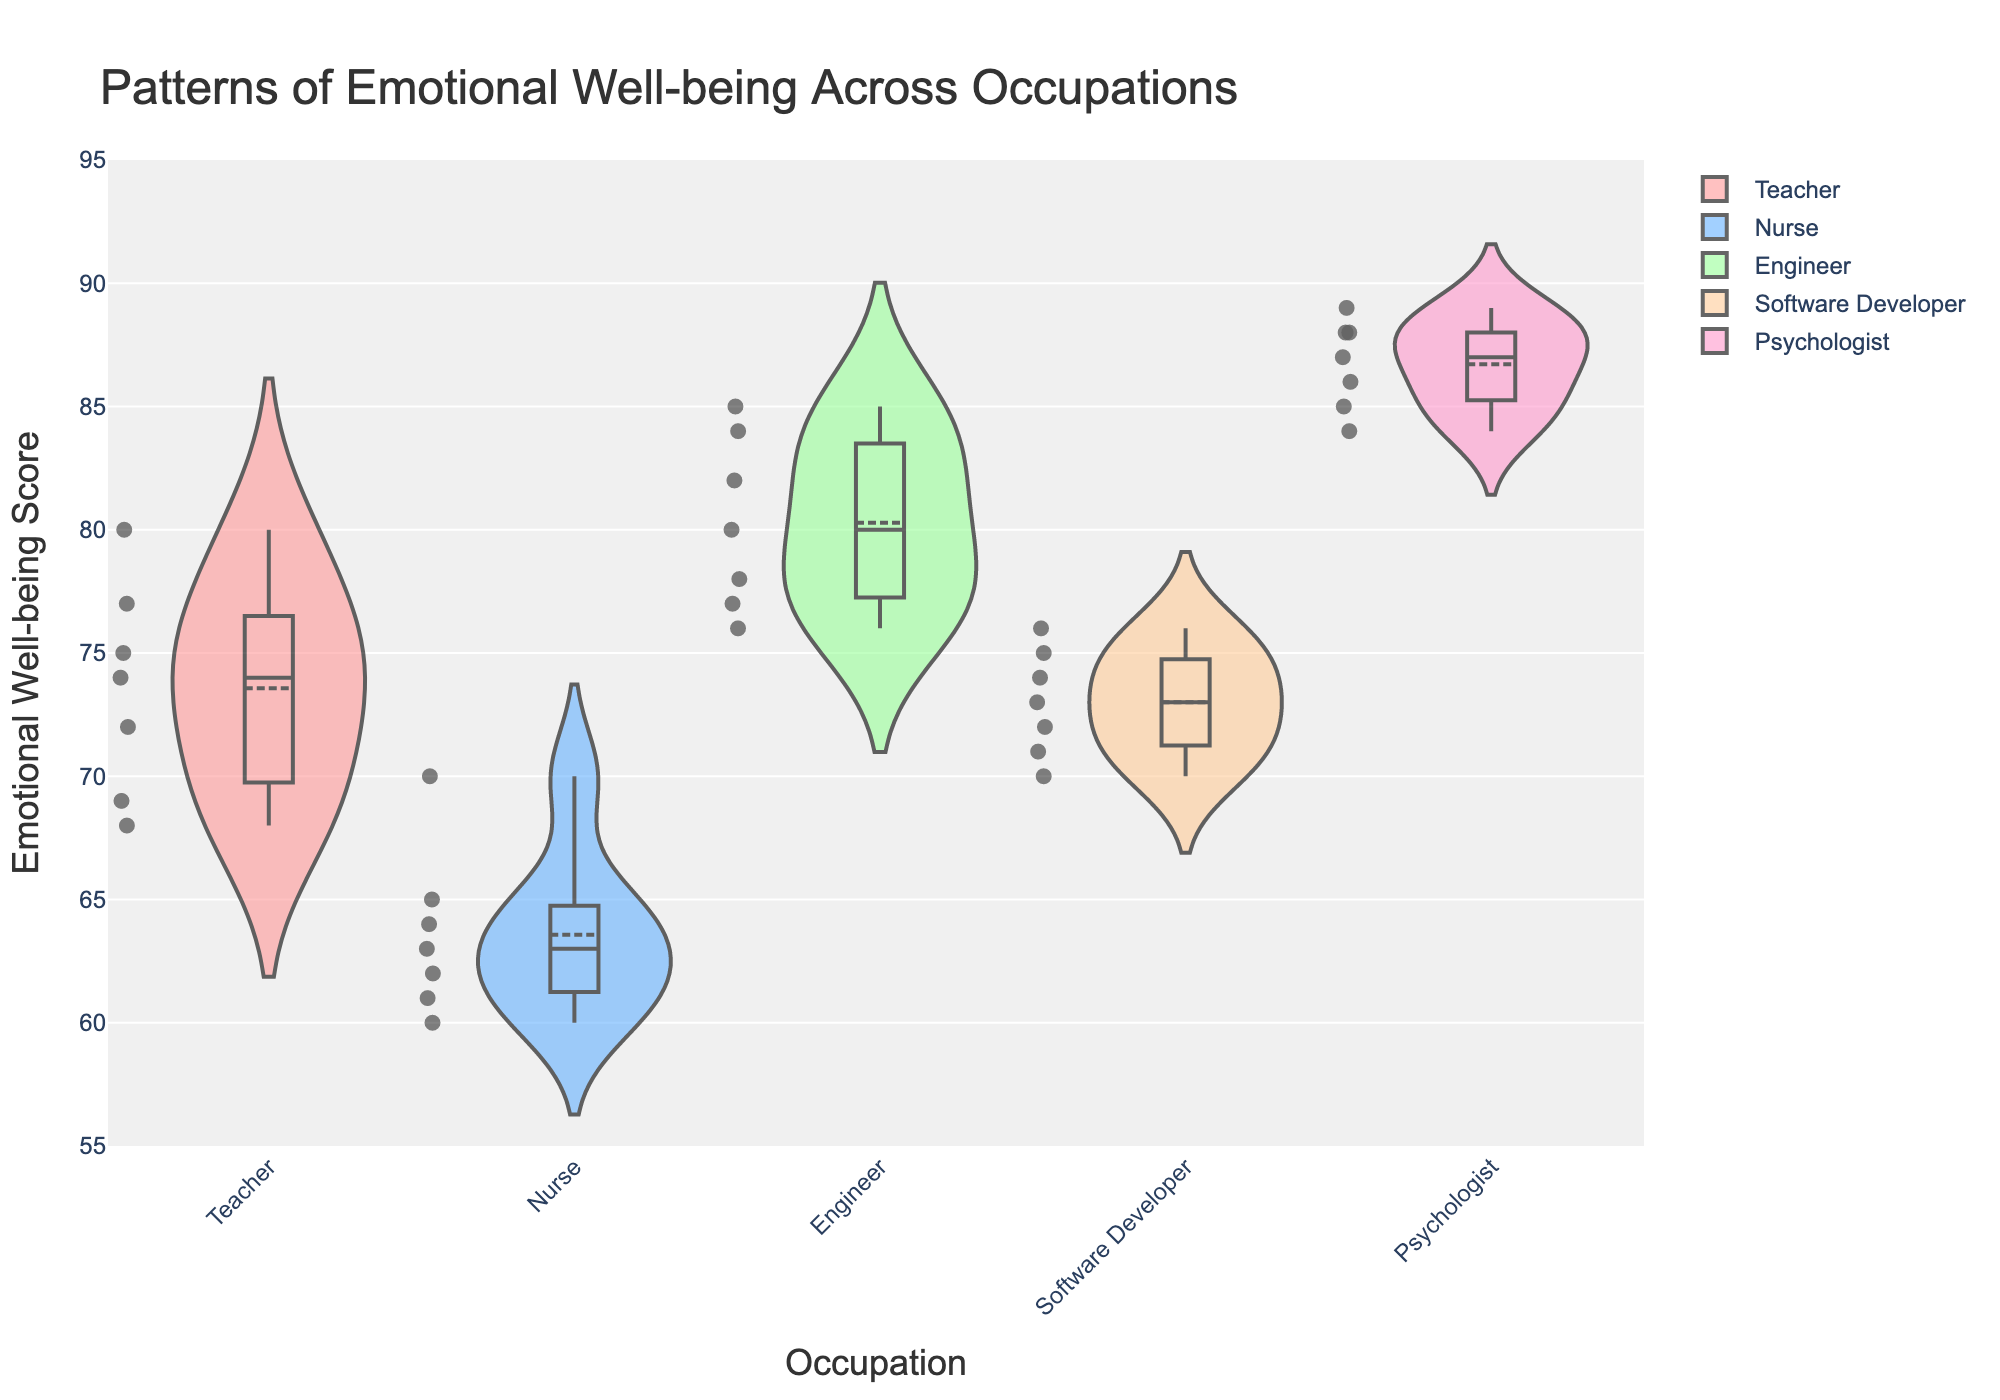What is the title of the figure? The title is typically found at the top or above the plot, clearly indicating the purpose of the figure. In this case, the title is 'Patterns of Emotional Well-being Across Occupations'.
Answer: 'Patterns of Emotional Well-being Across Occupations' What is the range of the y-axis? The y-axis range indicates the span of the numerical values being plotted for emotional well-being scores. From the plot, the range is from 55 to 95.
Answer: 55 to 95 Which occupation has the highest median emotional well-being score? The median score is indicated by the central line in the box plot. For psychologists, this line is higher than for any other occupation.
Answer: Psychologist Which occupation has the most spread-out emotional well-being scores? The spread can be seen by the width of the violin plot and the length of the box plot. Nurses have a wider violin plot and a longer box between the lower and upper quartiles compared to other occupations.
Answer: Nurse What is the approximate mean emotional well-being score for Software Developers? The mean is marked by a distinct line in the middle of the box plot. For Software Developers, this line appears around the value of 73.
Answer: 73 Are there any outliers in the emotional well-being scores for Engineers? Outliers in a box plot are typically indicated by individual points outside the whiskers. There are no isolated points for Engineers, indicating no outliers.
Answer: No Which two occupations have the closest median emotional well-being scores? The median scores are the central lines in the box plots. Teachers and Software Developers have median scores that appear very close to each other.
Answer: Teacher and Software Developer How does the variance of emotional well-being in Teachers compare to Psychologists? Variance can be seen by comparing the width of the violin plots and the interquartile range in the box plots. Teachers have a narrower violin and smaller interquartile range compared to Psychologists, indicating less variance.
Answer: Less for Teachers What is the emotional well-being score range for Nurses? The score range can be determined by looking at the top and bottom of the box plot whiskers for Nurses, which extend from about 60 to 70.
Answer: 60 to 70 Are the emotional well-being scores for Teachers normally distributed? Normal distribution in a violin plot appears as a symmetric shape about the vertical axis. The violin plot for Teachers is relatively symmetric.
Answer: Relatively symmetric 